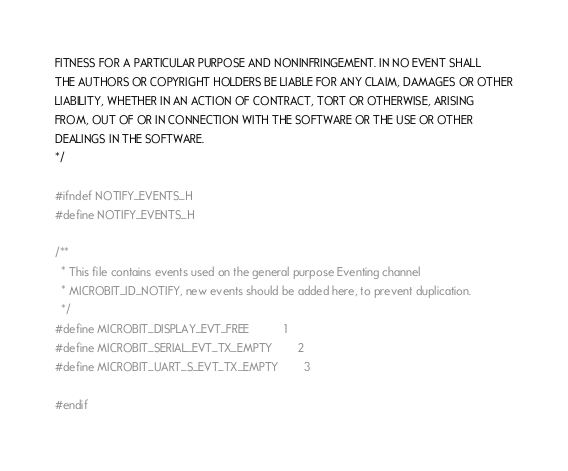<code> <loc_0><loc_0><loc_500><loc_500><_C_>FITNESS FOR A PARTICULAR PURPOSE AND NONINFRINGEMENT. IN NO EVENT SHALL
THE AUTHORS OR COPYRIGHT HOLDERS BE LIABLE FOR ANY CLAIM, DAMAGES OR OTHER
LIABILITY, WHETHER IN AN ACTION OF CONTRACT, TORT OR OTHERWISE, ARISING
FROM, OUT OF OR IN CONNECTION WITH THE SOFTWARE OR THE USE OR OTHER
DEALINGS IN THE SOFTWARE.
*/

#ifndef NOTIFY_EVENTS_H
#define NOTIFY_EVENTS_H

/**
  * This file contains events used on the general purpose Eventing channel
  * MICROBIT_ID_NOTIFY, new events should be added here, to prevent duplication.
  */
#define MICROBIT_DISPLAY_EVT_FREE           1
#define MICROBIT_SERIAL_EVT_TX_EMPTY        2
#define MICROBIT_UART_S_EVT_TX_EMPTY        3

#endif
</code> 